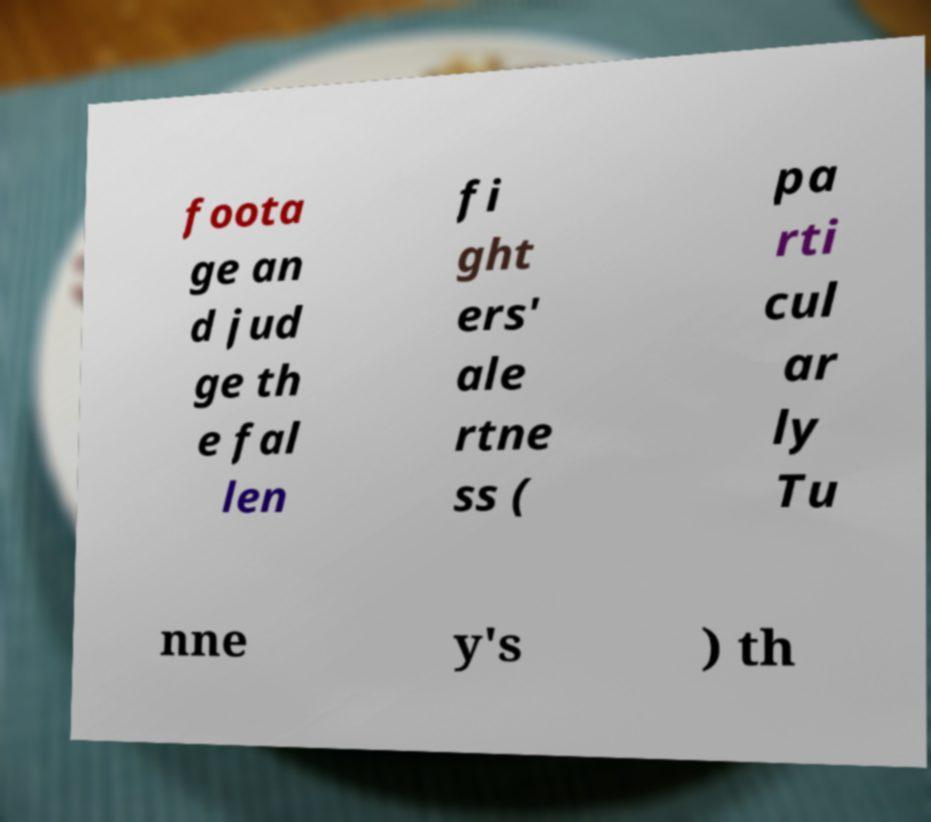Please identify and transcribe the text found in this image. foota ge an d jud ge th e fal len fi ght ers' ale rtne ss ( pa rti cul ar ly Tu nne y's ) th 